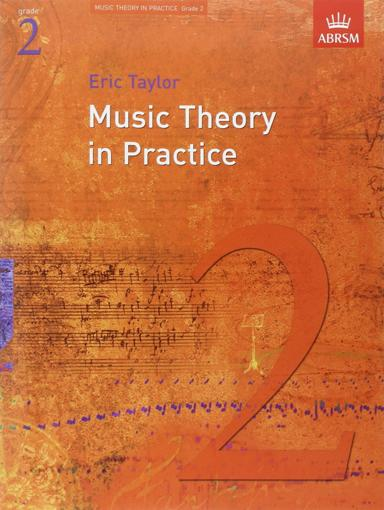Who is the author of the book in the image? The author of the book prominently displayed in the image is Eric Taylor, a renowned educator known for his extensive work in music theory. His books are widely used by students preparing for their ABRSM exams. 